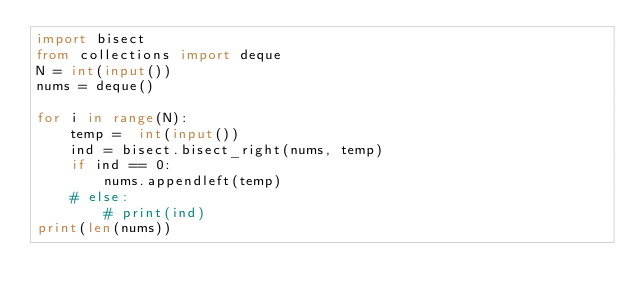<code> <loc_0><loc_0><loc_500><loc_500><_Python_>import bisect
from collections import deque
N = int(input())
nums = deque()

for i in range(N):
    temp =  int(input())
    ind = bisect.bisect_right(nums, temp)
    if ind == 0:
        nums.appendleft(temp)
    # else:
        # print(ind)
print(len(nums))</code> 